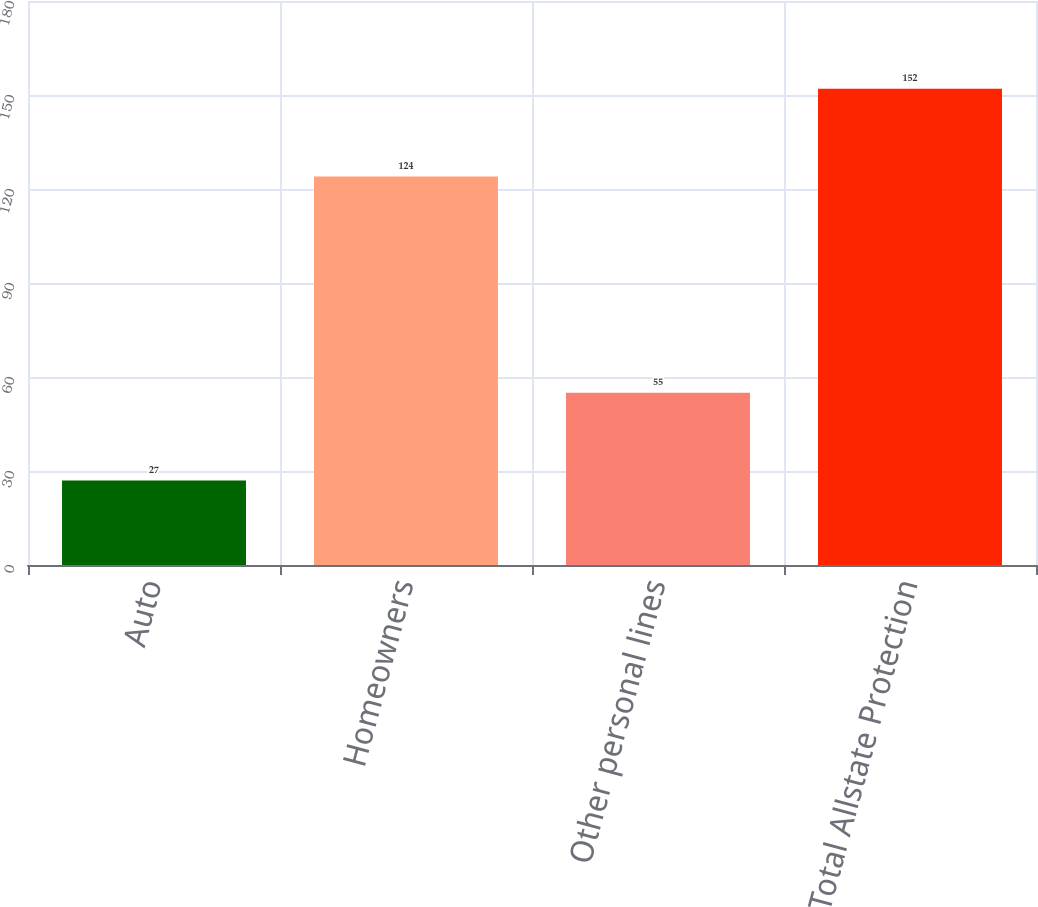<chart> <loc_0><loc_0><loc_500><loc_500><bar_chart><fcel>Auto<fcel>Homeowners<fcel>Other personal lines<fcel>Total Allstate Protection<nl><fcel>27<fcel>124<fcel>55<fcel>152<nl></chart> 